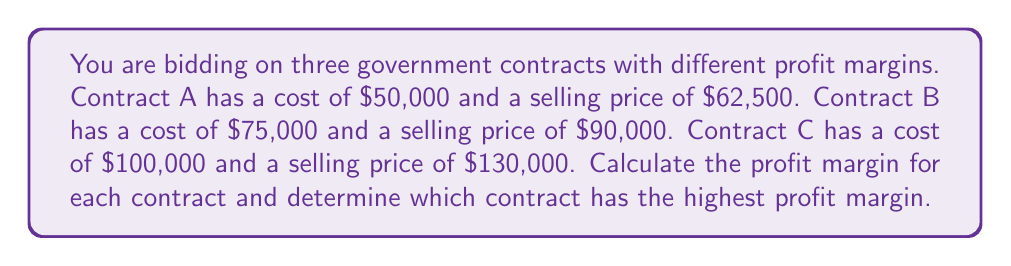Can you answer this question? To calculate the profit margin for each contract, we'll use the formula:

Profit Margin = $\frac{\text{Profit}}{\text{Selling Price}} \times 100\%$

Where Profit = Selling Price - Cost

For Contract A:
Profit = $62,500 - $50,000 = $12,500
Profit Margin = $\frac{12,500}{62,500} \times 100\% = 20\%$

For Contract B:
Profit = $90,000 - $75,000 = $15,000
Profit Margin = $\frac{15,000}{90,000} \times 100\% = 16.67\%$

For Contract C:
Profit = $130,000 - $100,000 = $30,000
Profit Margin = $\frac{30,000}{130,000} \times 100\% = 23.08\%$

Comparing the profit margins:
Contract A: 20%
Contract B: 16.67%
Contract C: 23.08%

Contract C has the highest profit margin at 23.08%.
Answer: Contract C: 23.08% 